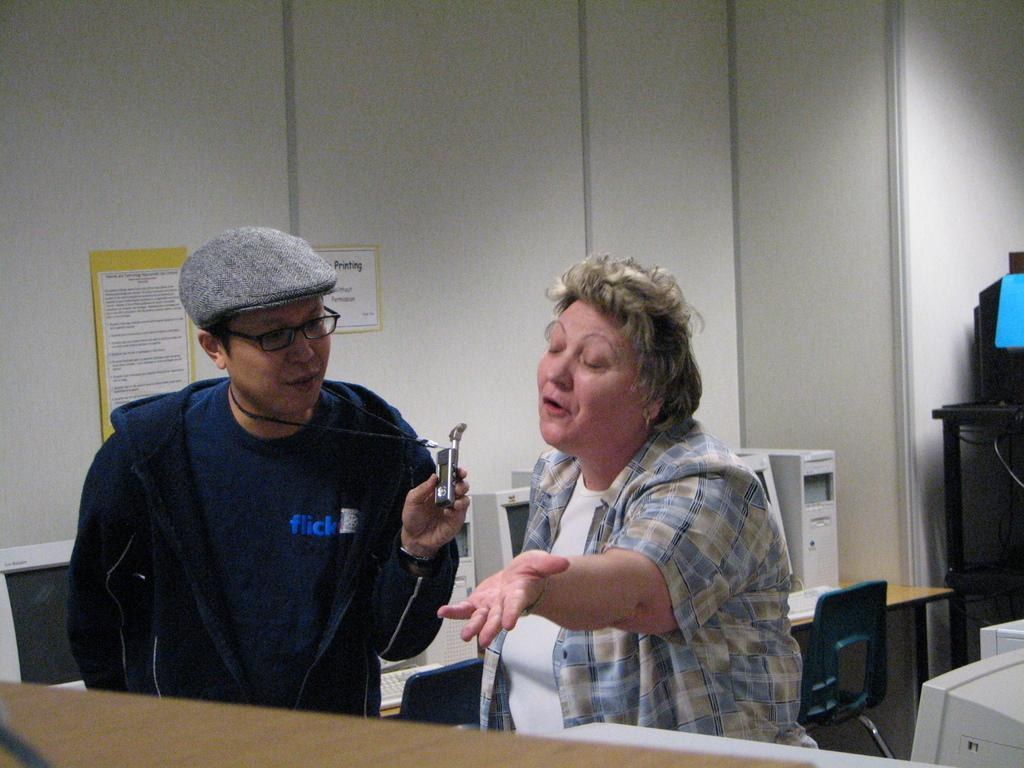Who is present in the image? There is a woman and a man in the image. What is the woman doing in the image? The woman is talking in the image. What is the woman wearing in the image? The woman is wearing a shirt in the image. What is the man wearing in the image? The man is wearing a coat, cap, and spectacles in the image. What is the setting of the image? The setting appears to be an office. What type of crayon is the woman using to draw on the wall in the image? There is no crayon or drawing on the wall present in the image. 